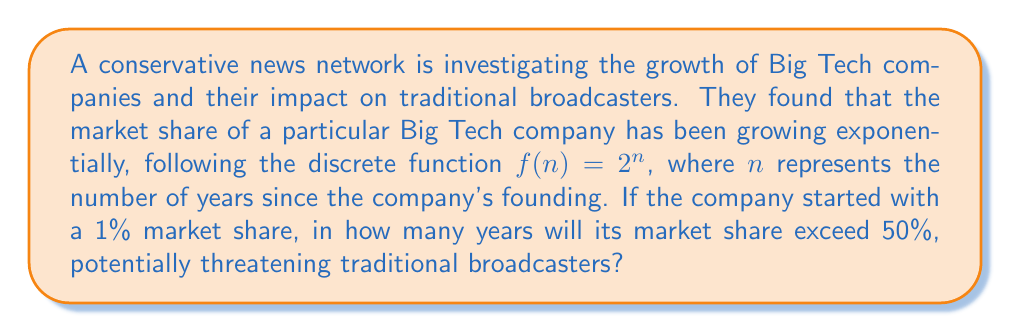What is the answer to this math problem? To solve this problem, we need to find the smallest value of $n$ for which $f(n) > 50$.

Given:
- The growth function is $f(n) = 2^n$
- The initial market share is 1%

Step 1: Set up the inequality
We want to find $n$ where:
$2^n \cdot 1\% > 50\%$

Step 2: Convert percentages to decimals
$2^n \cdot 0.01 > 0.5$

Step 3: Divide both sides by 0.01
$2^n > 50$

Step 4: Take the logarithm (base 2) of both sides
$\log_2(2^n) > \log_2(50)$
$n > \log_2(50)$

Step 5: Calculate $\log_2(50)$
$\log_2(50) \approx 5.64$

Step 6: Find the smallest integer $n$ that satisfies the inequality
The smallest integer greater than 5.64 is 6.

Therefore, in 6 years, the Big Tech company's market share will exceed 50%.

To verify:
$f(5) = 2^5 \cdot 1\% = 32\% < 50\%$
$f(6) = 2^6 \cdot 1\% = 64\% > 50\%$
Answer: 6 years 